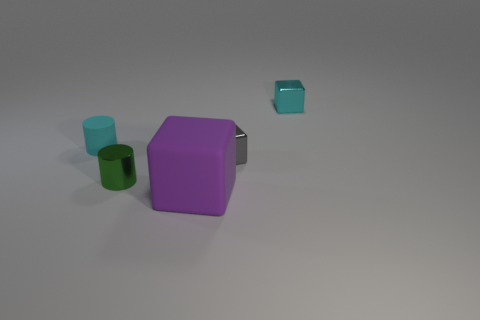Subtract all small metal blocks. How many blocks are left? 1 Add 2 cyan metal objects. How many objects exist? 7 Subtract all gray blocks. How many blocks are left? 2 Subtract all cylinders. How many objects are left? 3 Subtract 1 gray cubes. How many objects are left? 4 Subtract all blue cylinders. Subtract all yellow cubes. How many cylinders are left? 2 Subtract all matte cylinders. Subtract all small shiny cylinders. How many objects are left? 3 Add 3 gray things. How many gray things are left? 4 Add 4 large blocks. How many large blocks exist? 5 